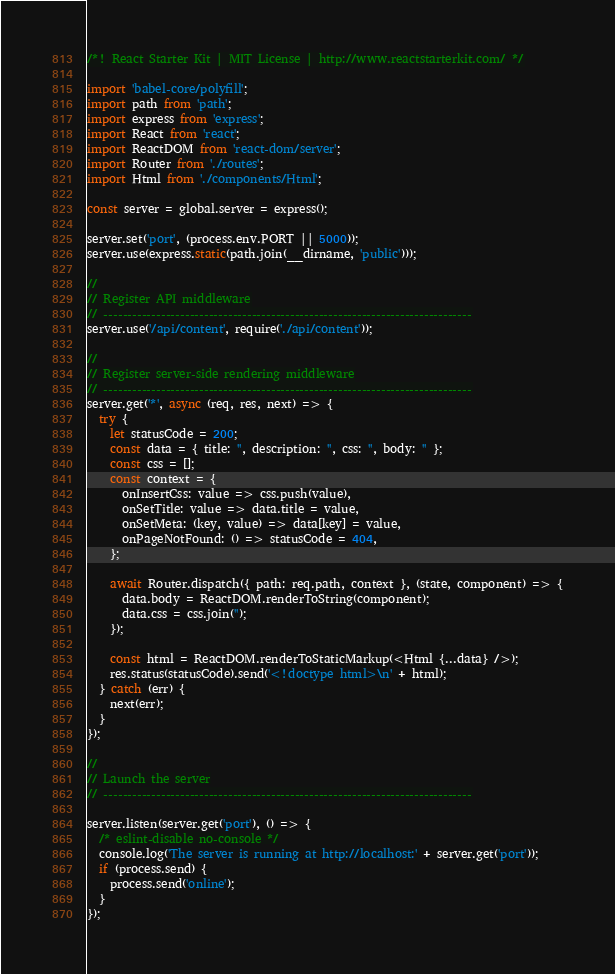<code> <loc_0><loc_0><loc_500><loc_500><_JavaScript_>/*! React Starter Kit | MIT License | http://www.reactstarterkit.com/ */

import 'babel-core/polyfill';
import path from 'path';
import express from 'express';
import React from 'react';
import ReactDOM from 'react-dom/server';
import Router from './routes';
import Html from './components/Html';

const server = global.server = express();

server.set('port', (process.env.PORT || 5000));
server.use(express.static(path.join(__dirname, 'public')));

//
// Register API middleware
// -----------------------------------------------------------------------------
server.use('/api/content', require('./api/content'));

//
// Register server-side rendering middleware
// -----------------------------------------------------------------------------
server.get('*', async (req, res, next) => {
  try {
    let statusCode = 200;
    const data = { title: '', description: '', css: '', body: '' };
    const css = [];
    const context = {
      onInsertCss: value => css.push(value),
      onSetTitle: value => data.title = value,
      onSetMeta: (key, value) => data[key] = value,
      onPageNotFound: () => statusCode = 404,
    };

    await Router.dispatch({ path: req.path, context }, (state, component) => {
      data.body = ReactDOM.renderToString(component);
      data.css = css.join('');
    });

    const html = ReactDOM.renderToStaticMarkup(<Html {...data} />);
    res.status(statusCode).send('<!doctype html>\n' + html);
  } catch (err) {
    next(err);
  }
});

//
// Launch the server
// -----------------------------------------------------------------------------

server.listen(server.get('port'), () => {
  /* eslint-disable no-console */
  console.log('The server is running at http://localhost:' + server.get('port'));
  if (process.send) {
    process.send('online');
  }
});
</code> 